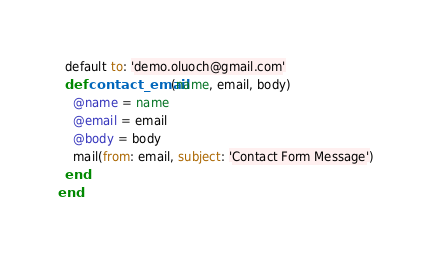<code> <loc_0><loc_0><loc_500><loc_500><_Ruby_>  default to: 'demo.oluoch@gmail.com'
  def contact_email(name, email, body)
    @name = name
    @email = email
    @body = body
    mail(from: email, subject: 'Contact Form Message')
  end
end
</code> 